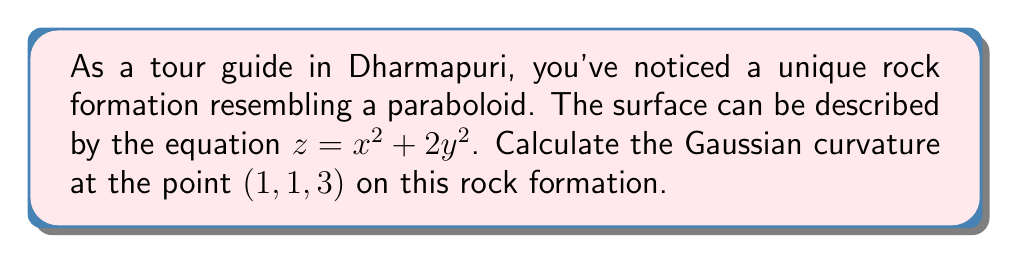Teach me how to tackle this problem. To find the Gaussian curvature, we need to follow these steps:

1) First, let's recall that for a surface $z = f(x,y)$, the Gaussian curvature K is given by:

   $$K = \frac{f_{xx}f_{yy} - f_{xy}^2}{(1 + f_x^2 + f_y^2)^2}$$

   where subscripts denote partial derivatives.

2) For our surface $z = x^2 + 2y^2$, let's calculate the partial derivatives:
   
   $f_x = 2x$
   $f_y = 4y$
   $f_{xx} = 2$
   $f_{yy} = 4$
   $f_{xy} = 0$

3) Now, let's substitute these into our formula:

   $$K = \frac{(2)(4) - (0)^2}{(1 + (2x)^2 + (4y)^2)^2}$$

4) Simplify:

   $$K = \frac{8}{(1 + 4x^2 + 16y^2)^2}$$

5) Now, we need to evaluate this at the point (1, 1, 3):

   $$K = \frac{8}{(1 + 4(1)^2 + 16(1)^2)^2} = \frac{8}{(1 + 4 + 16)^2} = \frac{8}{21^2} = \frac{8}{441}$$

Therefore, the Gaussian curvature at the point (1, 1, 3) is $\frac{8}{441}$.
Answer: $\frac{8}{441}$ 